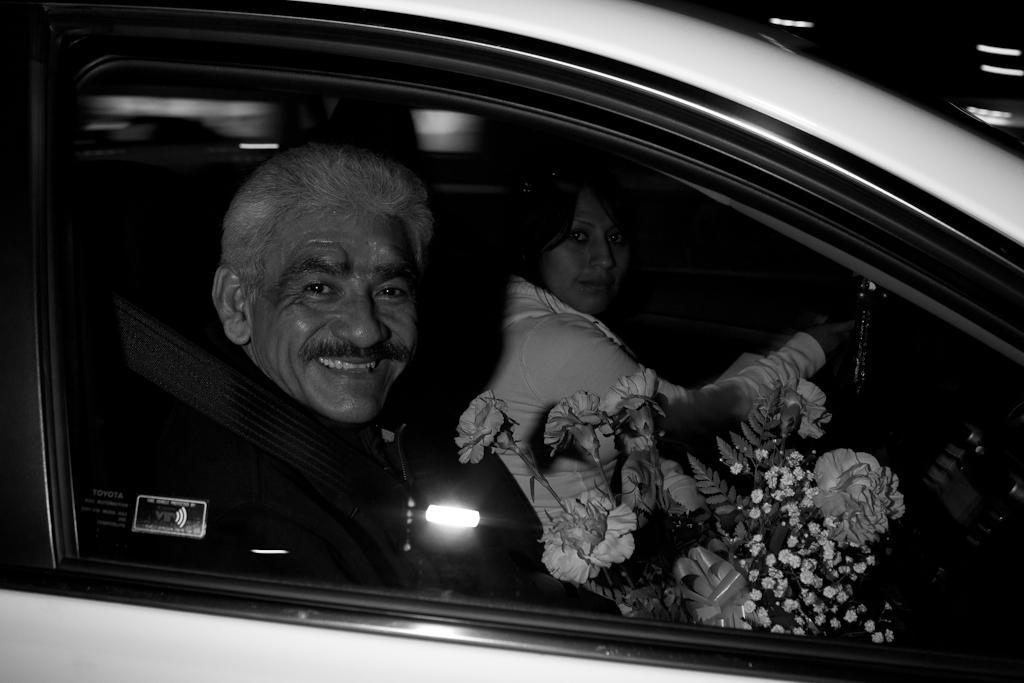How would you summarize this image in a sentence or two? In this picture two people are inside a car and the man has some beautiful flowers in his hand. 